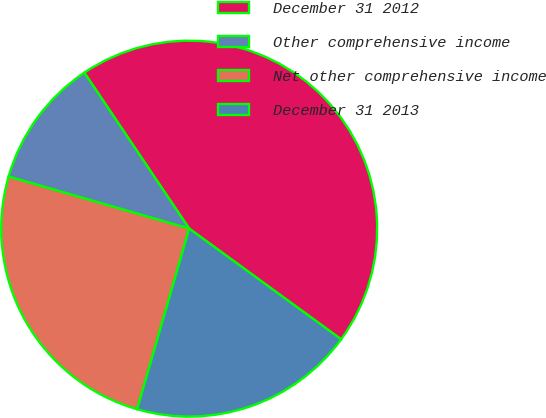<chart> <loc_0><loc_0><loc_500><loc_500><pie_chart><fcel>December 31 2012<fcel>Other comprehensive income<fcel>Net other comprehensive income<fcel>December 31 2013<nl><fcel>44.44%<fcel>11.11%<fcel>25.0%<fcel>19.44%<nl></chart> 